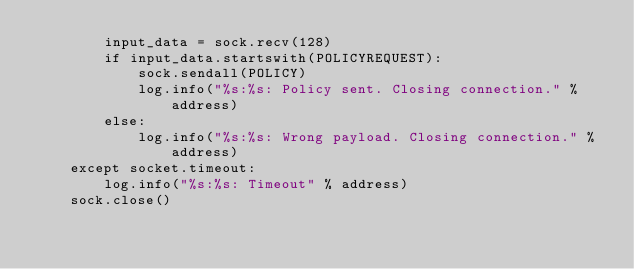Convert code to text. <code><loc_0><loc_0><loc_500><loc_500><_Python_>        input_data = sock.recv(128)
        if input_data.startswith(POLICYREQUEST):
            sock.sendall(POLICY)
            log.info("%s:%s: Policy sent. Closing connection." % address)
        else:
            log.info("%s:%s: Wrong payload. Closing connection." % address)
    except socket.timeout:
        log.info("%s:%s: Timeout" % address)
    sock.close()
</code> 